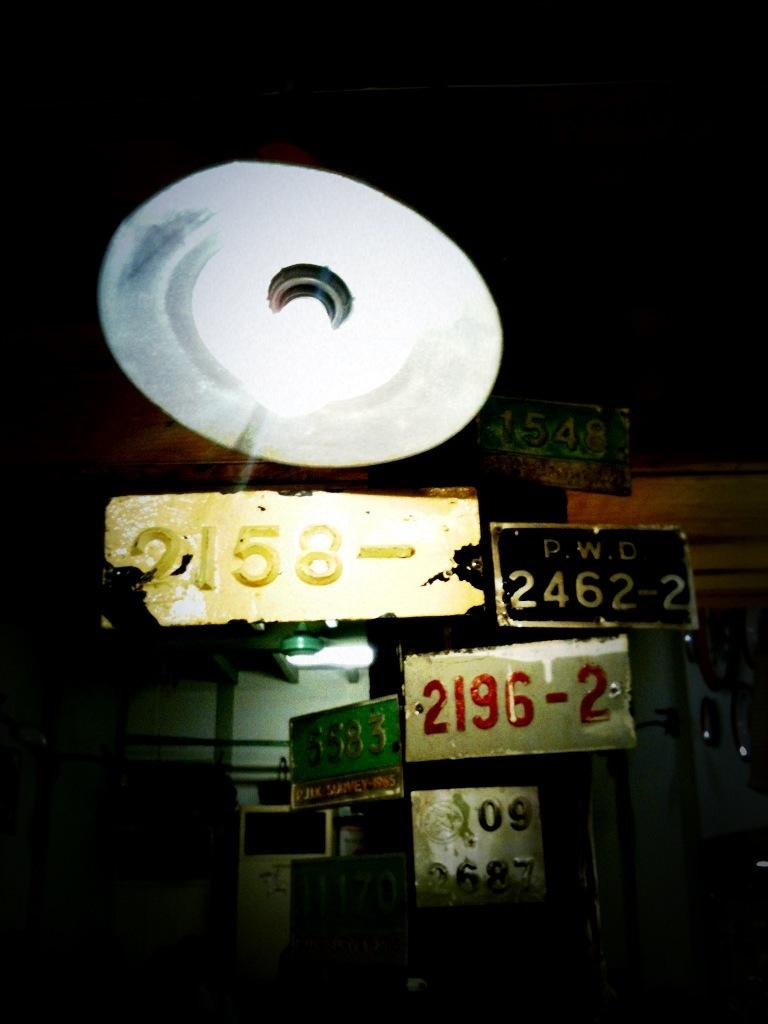<image>
Provide a brief description of the given image. A 2196-2 license plate along with others posted on a wall. 